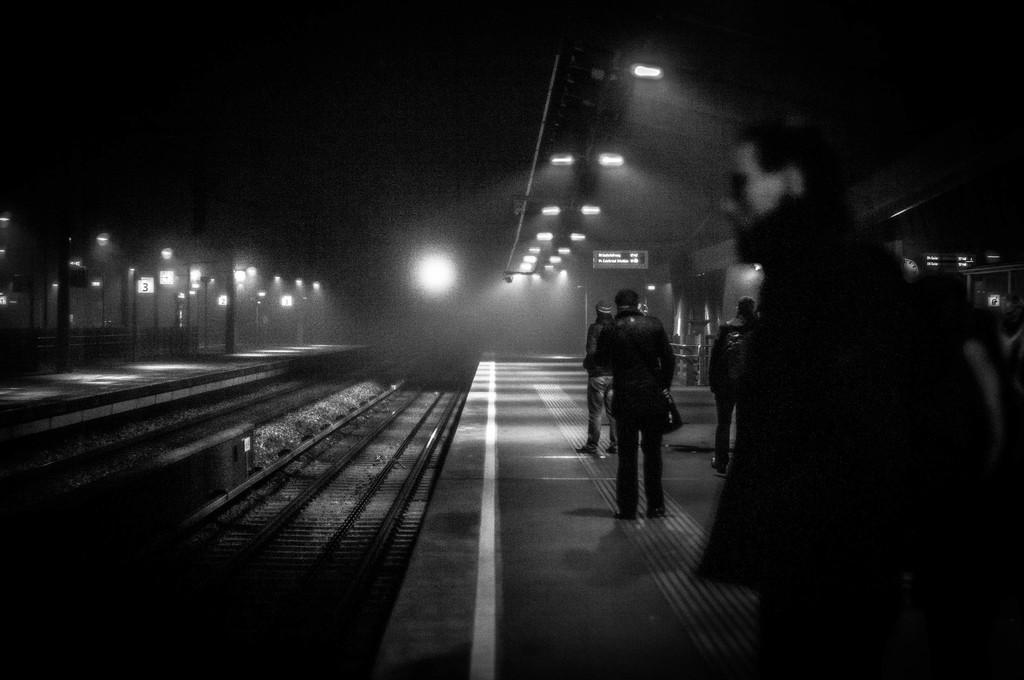What can be seen in the image? There are persons standing in the image. What else is visible in the image besides the persons? There are tracks visible in the image. What can be seen in the background of the image? There are lights in the background of the image. How many balls are being juggled by the persons in the image? There are no balls visible in the image, so it cannot be determined how many balls might be being juggled. 